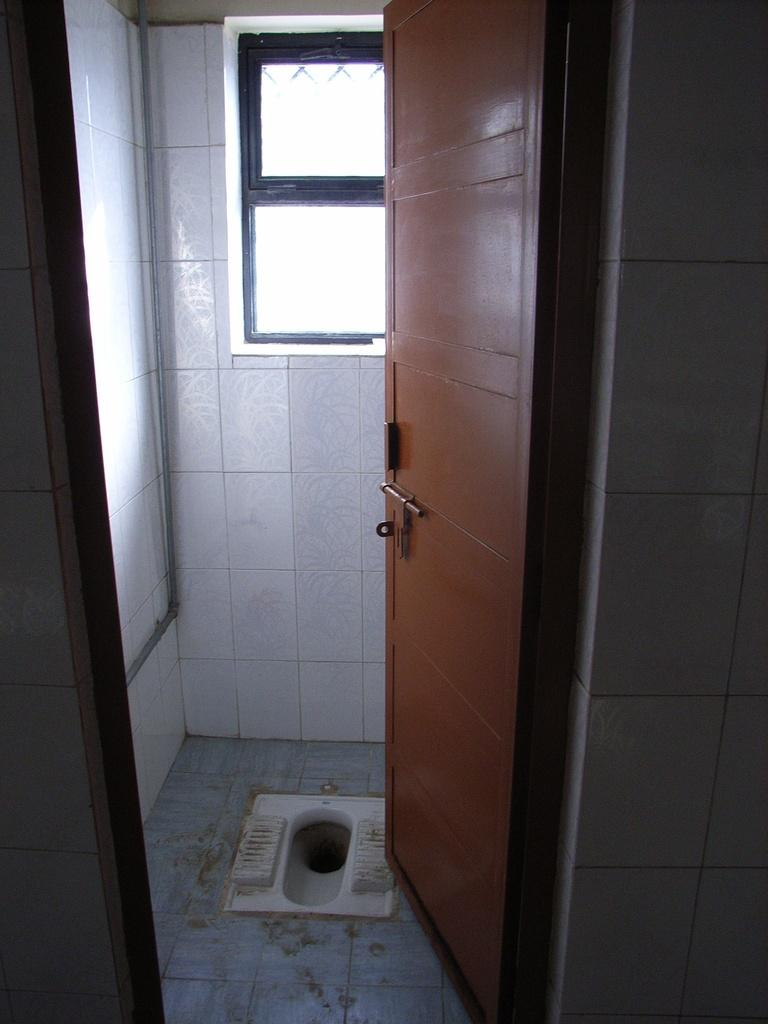What is the main object in the image? There is a toilet in the image. What is the purpose of the door in the image? The door in the image provides access to the room containing the toilet. What can be seen through the windows in the image? The windows in the image allow light to enter the room and provide a view of the outside. What is the function of the pipe in the image? The pipe in the image is likely used for plumbing purposes, such as carrying water or waste. What surrounds the toilet in the image? There are walls in the image that enclose the toilet and other fixtures. How many people are in the crowd gathered around the toilet in the image? There is no crowd present in the image; it only shows the toilet and other fixtures in a room. 